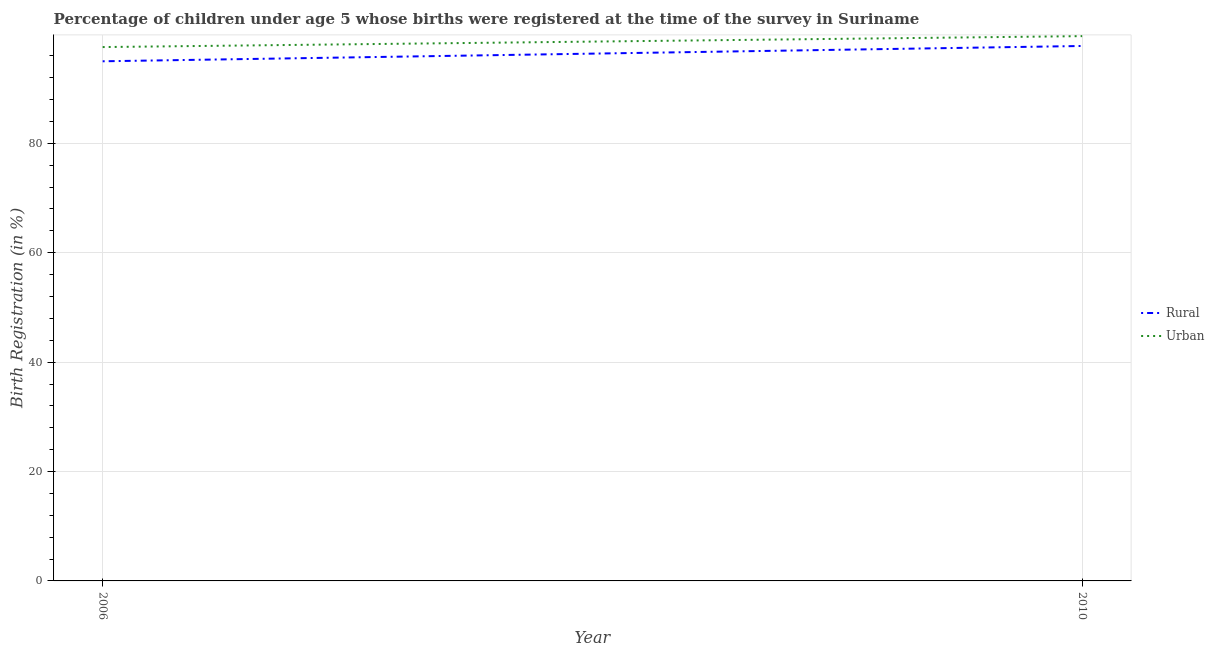What is the urban birth registration in 2006?
Your response must be concise. 97.6. Across all years, what is the maximum urban birth registration?
Ensure brevity in your answer.  99.6. In which year was the rural birth registration minimum?
Ensure brevity in your answer.  2006. What is the total urban birth registration in the graph?
Keep it short and to the point. 197.2. What is the difference between the urban birth registration in 2010 and the rural birth registration in 2006?
Keep it short and to the point. 4.6. What is the average urban birth registration per year?
Make the answer very short. 98.6. In the year 2006, what is the difference between the urban birth registration and rural birth registration?
Offer a very short reply. 2.6. In how many years, is the urban birth registration greater than 80 %?
Provide a short and direct response. 2. What is the ratio of the urban birth registration in 2006 to that in 2010?
Ensure brevity in your answer.  0.98. Is the rural birth registration in 2006 less than that in 2010?
Ensure brevity in your answer.  Yes. In how many years, is the urban birth registration greater than the average urban birth registration taken over all years?
Provide a succinct answer. 1. Does the rural birth registration monotonically increase over the years?
Offer a very short reply. Yes. Is the rural birth registration strictly greater than the urban birth registration over the years?
Your response must be concise. No. Is the urban birth registration strictly less than the rural birth registration over the years?
Your response must be concise. No. What is the difference between two consecutive major ticks on the Y-axis?
Provide a short and direct response. 20. Does the graph contain any zero values?
Keep it short and to the point. No. Where does the legend appear in the graph?
Ensure brevity in your answer.  Center right. How many legend labels are there?
Your answer should be compact. 2. What is the title of the graph?
Your answer should be compact. Percentage of children under age 5 whose births were registered at the time of the survey in Suriname. What is the label or title of the Y-axis?
Ensure brevity in your answer.  Birth Registration (in %). What is the Birth Registration (in %) of Urban in 2006?
Provide a short and direct response. 97.6. What is the Birth Registration (in %) of Rural in 2010?
Offer a terse response. 97.8. What is the Birth Registration (in %) of Urban in 2010?
Your answer should be compact. 99.6. Across all years, what is the maximum Birth Registration (in %) of Rural?
Keep it short and to the point. 97.8. Across all years, what is the maximum Birth Registration (in %) of Urban?
Ensure brevity in your answer.  99.6. Across all years, what is the minimum Birth Registration (in %) of Urban?
Make the answer very short. 97.6. What is the total Birth Registration (in %) of Rural in the graph?
Offer a terse response. 192.8. What is the total Birth Registration (in %) in Urban in the graph?
Ensure brevity in your answer.  197.2. What is the difference between the Birth Registration (in %) of Urban in 2006 and that in 2010?
Offer a terse response. -2. What is the difference between the Birth Registration (in %) in Rural in 2006 and the Birth Registration (in %) in Urban in 2010?
Your answer should be compact. -4.6. What is the average Birth Registration (in %) of Rural per year?
Provide a short and direct response. 96.4. What is the average Birth Registration (in %) of Urban per year?
Your answer should be compact. 98.6. What is the ratio of the Birth Registration (in %) in Rural in 2006 to that in 2010?
Provide a short and direct response. 0.97. What is the ratio of the Birth Registration (in %) in Urban in 2006 to that in 2010?
Make the answer very short. 0.98. What is the difference between the highest and the second highest Birth Registration (in %) in Urban?
Provide a short and direct response. 2. What is the difference between the highest and the lowest Birth Registration (in %) of Rural?
Give a very brief answer. 2.8. What is the difference between the highest and the lowest Birth Registration (in %) in Urban?
Your answer should be compact. 2. 